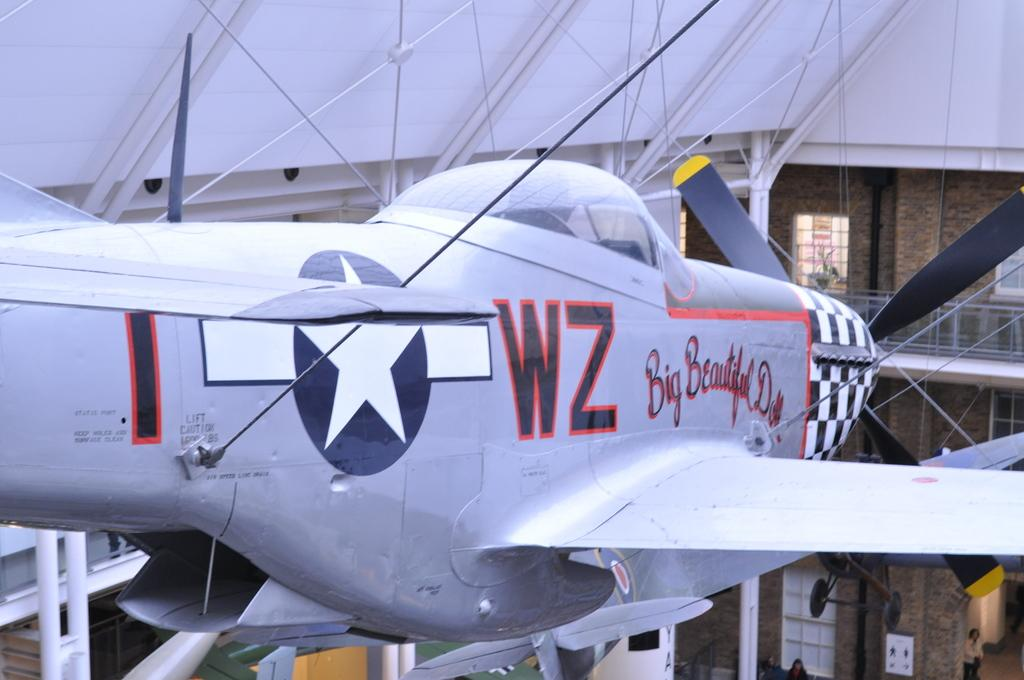What is the main subject of the image? The main subject of the image is an aircraft. What else can be seen in the image besides the aircraft? There are rods visible in the image, as well as a building with windows. Are there any people present in the image? Yes, there are people at the bottom of the image. What unit of measurement is used to determine the distance between the aircraft and the building in the image? The provided facts do not mention any specific unit of measurement, so it cannot be determined from the image. 